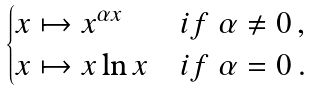<formula> <loc_0><loc_0><loc_500><loc_500>\begin{cases} x \mapsto x ^ { \alpha x } & i f \ \alpha \ne 0 \, , \\ x \mapsto x \ln x & i f \ \alpha = 0 \, . \end{cases}</formula> 